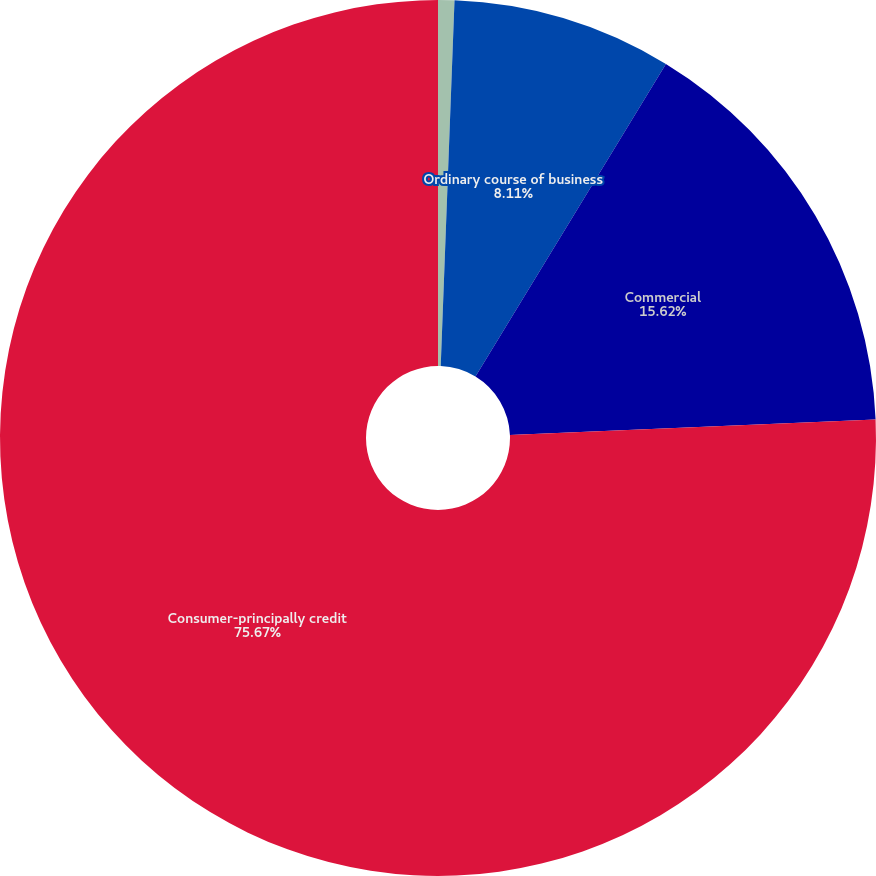<chart> <loc_0><loc_0><loc_500><loc_500><pie_chart><fcel>December 31 (In millions)<fcel>Ordinary course of business<fcel>Commercial<fcel>Consumer-principally credit<nl><fcel>0.6%<fcel>8.11%<fcel>15.62%<fcel>75.67%<nl></chart> 